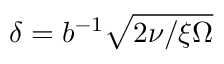Convert formula to latex. <formula><loc_0><loc_0><loc_500><loc_500>\delta = b ^ { - 1 } \sqrt { 2 \nu / \xi \Omega }</formula> 